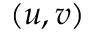<formula> <loc_0><loc_0><loc_500><loc_500>( u , v )</formula> 